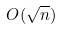Convert formula to latex. <formula><loc_0><loc_0><loc_500><loc_500>O ( \sqrt { n } )</formula> 